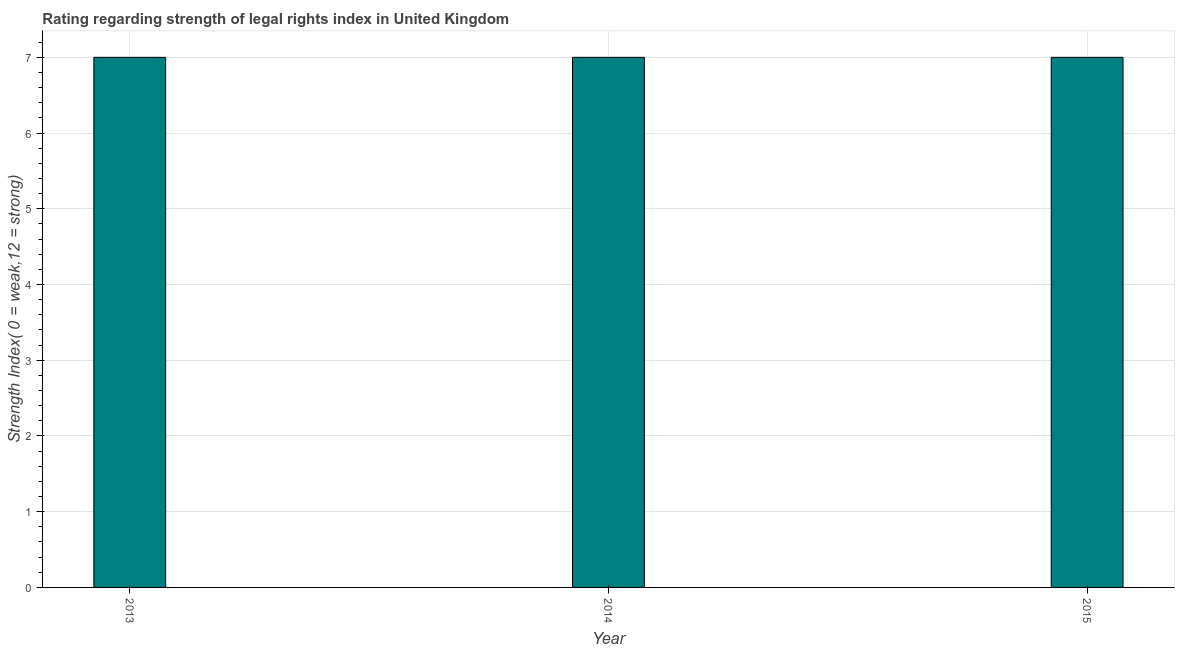Does the graph contain grids?
Your response must be concise. Yes. What is the title of the graph?
Your response must be concise. Rating regarding strength of legal rights index in United Kingdom. What is the label or title of the Y-axis?
Give a very brief answer. Strength Index( 0 = weak,12 = strong). What is the strength of legal rights index in 2015?
Your answer should be compact. 7. Across all years, what is the maximum strength of legal rights index?
Give a very brief answer. 7. In which year was the strength of legal rights index maximum?
Give a very brief answer. 2013. In which year was the strength of legal rights index minimum?
Offer a very short reply. 2013. What is the difference between the strength of legal rights index in 2014 and 2015?
Provide a succinct answer. 0. What is the median strength of legal rights index?
Offer a very short reply. 7. In how many years, is the strength of legal rights index greater than 1.6 ?
Provide a succinct answer. 3. Do a majority of the years between 2015 and 2013 (inclusive) have strength of legal rights index greater than 1.6 ?
Offer a very short reply. Yes. What is the difference between the highest and the second highest strength of legal rights index?
Offer a terse response. 0. In how many years, is the strength of legal rights index greater than the average strength of legal rights index taken over all years?
Keep it short and to the point. 0. Are all the bars in the graph horizontal?
Your response must be concise. No. What is the difference between two consecutive major ticks on the Y-axis?
Your response must be concise. 1. What is the Strength Index( 0 = weak,12 = strong) in 2013?
Give a very brief answer. 7. What is the Strength Index( 0 = weak,12 = strong) in 2014?
Your answer should be very brief. 7. What is the Strength Index( 0 = weak,12 = strong) in 2015?
Provide a succinct answer. 7. What is the difference between the Strength Index( 0 = weak,12 = strong) in 2013 and 2014?
Your response must be concise. 0. What is the ratio of the Strength Index( 0 = weak,12 = strong) in 2013 to that in 2015?
Offer a very short reply. 1. What is the ratio of the Strength Index( 0 = weak,12 = strong) in 2014 to that in 2015?
Provide a short and direct response. 1. 